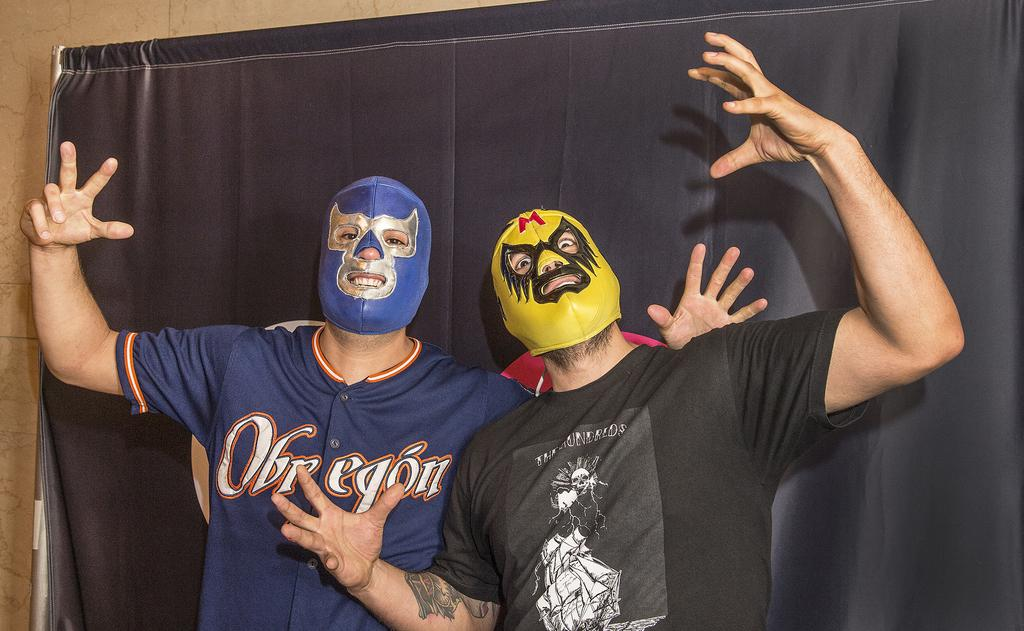How many people are in the foreground of the picture? There are two people in the foreground of the picture. What are the people wearing on their faces? The people are wearing masks. What color is the curtain behind the people? The curtain behind the people is black. What can be seen on the left side of the image? There is a well on the left side of the image. Can you see any wrens in the image? There are no wrens present in the image. 